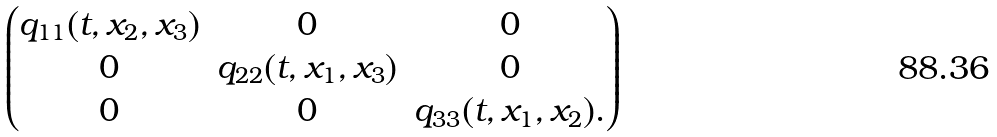Convert formula to latex. <formula><loc_0><loc_0><loc_500><loc_500>\begin{pmatrix} q _ { 1 1 } ( t , x _ { 2 } , x _ { 3 } ) & 0 & 0 \\ 0 & q _ { 2 2 } ( t , x _ { 1 } , x _ { 3 } ) & 0 \\ 0 & 0 & q _ { 3 3 } ( t , x _ { 1 } , x _ { 2 } ) . \end{pmatrix}</formula> 